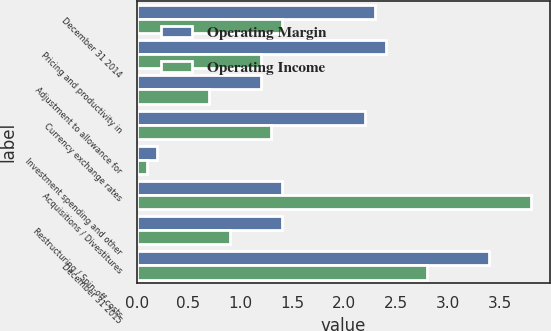Convert chart. <chart><loc_0><loc_0><loc_500><loc_500><stacked_bar_chart><ecel><fcel>December 31 2014<fcel>Pricing and productivity in<fcel>Adjustment to allowance for<fcel>Currency exchange rates<fcel>Investment spending and other<fcel>Acquisitions / Divestitures<fcel>Restructuring / Spin-off costs<fcel>December 31 2015<nl><fcel>Operating Margin<fcel>2.3<fcel>2.4<fcel>1.2<fcel>2.2<fcel>0.2<fcel>1.4<fcel>1.4<fcel>3.4<nl><fcel>Operating Income<fcel>1.4<fcel>1.2<fcel>0.7<fcel>1.3<fcel>0.1<fcel>3.8<fcel>0.9<fcel>2.8<nl></chart> 